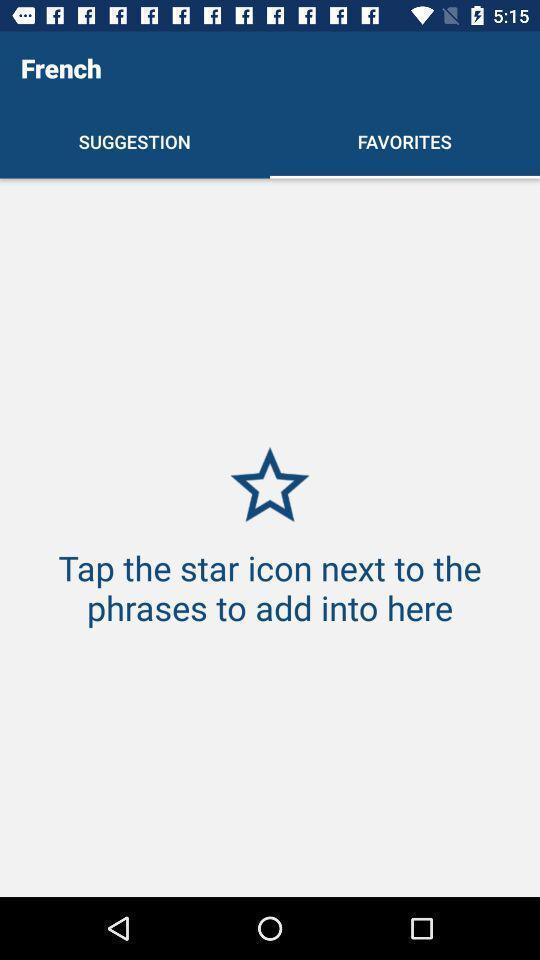Provide a textual representation of this image. Screen showing favorite page of a learning app. 